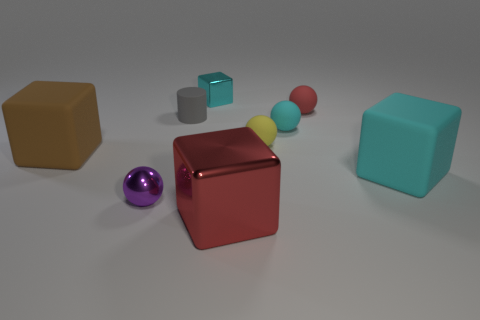There is a metal object that is in front of the tiny purple shiny sphere; what is its color?
Your answer should be very brief. Red. Is the object in front of the purple ball made of the same material as the gray cylinder?
Ensure brevity in your answer.  No. What number of spheres are both in front of the tiny yellow rubber object and to the right of the gray rubber cylinder?
Your response must be concise. 0. There is a thing in front of the tiny purple object in front of the cyan thing to the right of the cyan rubber sphere; what is its color?
Offer a very short reply. Red. What number of other things are the same shape as the small gray rubber object?
Offer a very short reply. 0. Are there any tiny yellow matte things in front of the red object in front of the yellow thing?
Provide a short and direct response. No. How many matte things are either large cyan cylinders or large red objects?
Offer a very short reply. 0. What is the material of the large block that is both left of the large cyan matte thing and right of the gray cylinder?
Your response must be concise. Metal. Is there a tiny cyan shiny cube to the left of the cyan rubber object behind the big matte cube that is right of the brown object?
Give a very brief answer. Yes. Is there any other thing that is the same material as the tiny cube?
Give a very brief answer. Yes. 